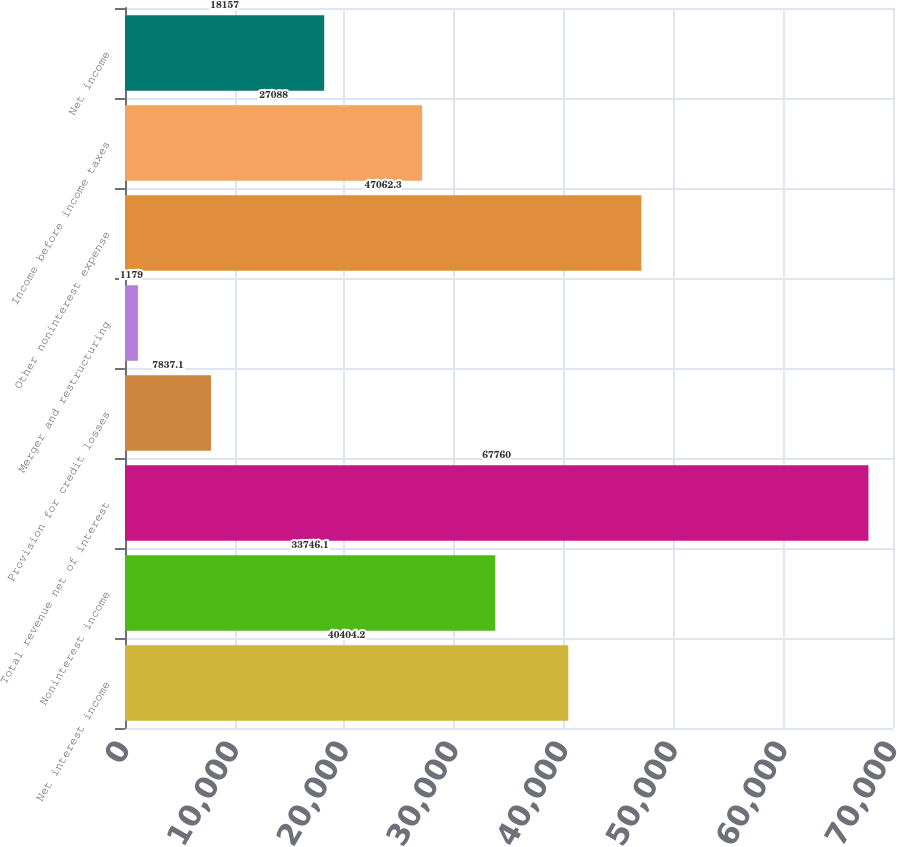<chart> <loc_0><loc_0><loc_500><loc_500><bar_chart><fcel>Net interest income<fcel>Noninterest income<fcel>Total revenue net of interest<fcel>Provision for credit losses<fcel>Merger and restructuring<fcel>Other noninterest expense<fcel>Income before income taxes<fcel>Net income<nl><fcel>40404.2<fcel>33746.1<fcel>67760<fcel>7837.1<fcel>1179<fcel>47062.3<fcel>27088<fcel>18157<nl></chart> 